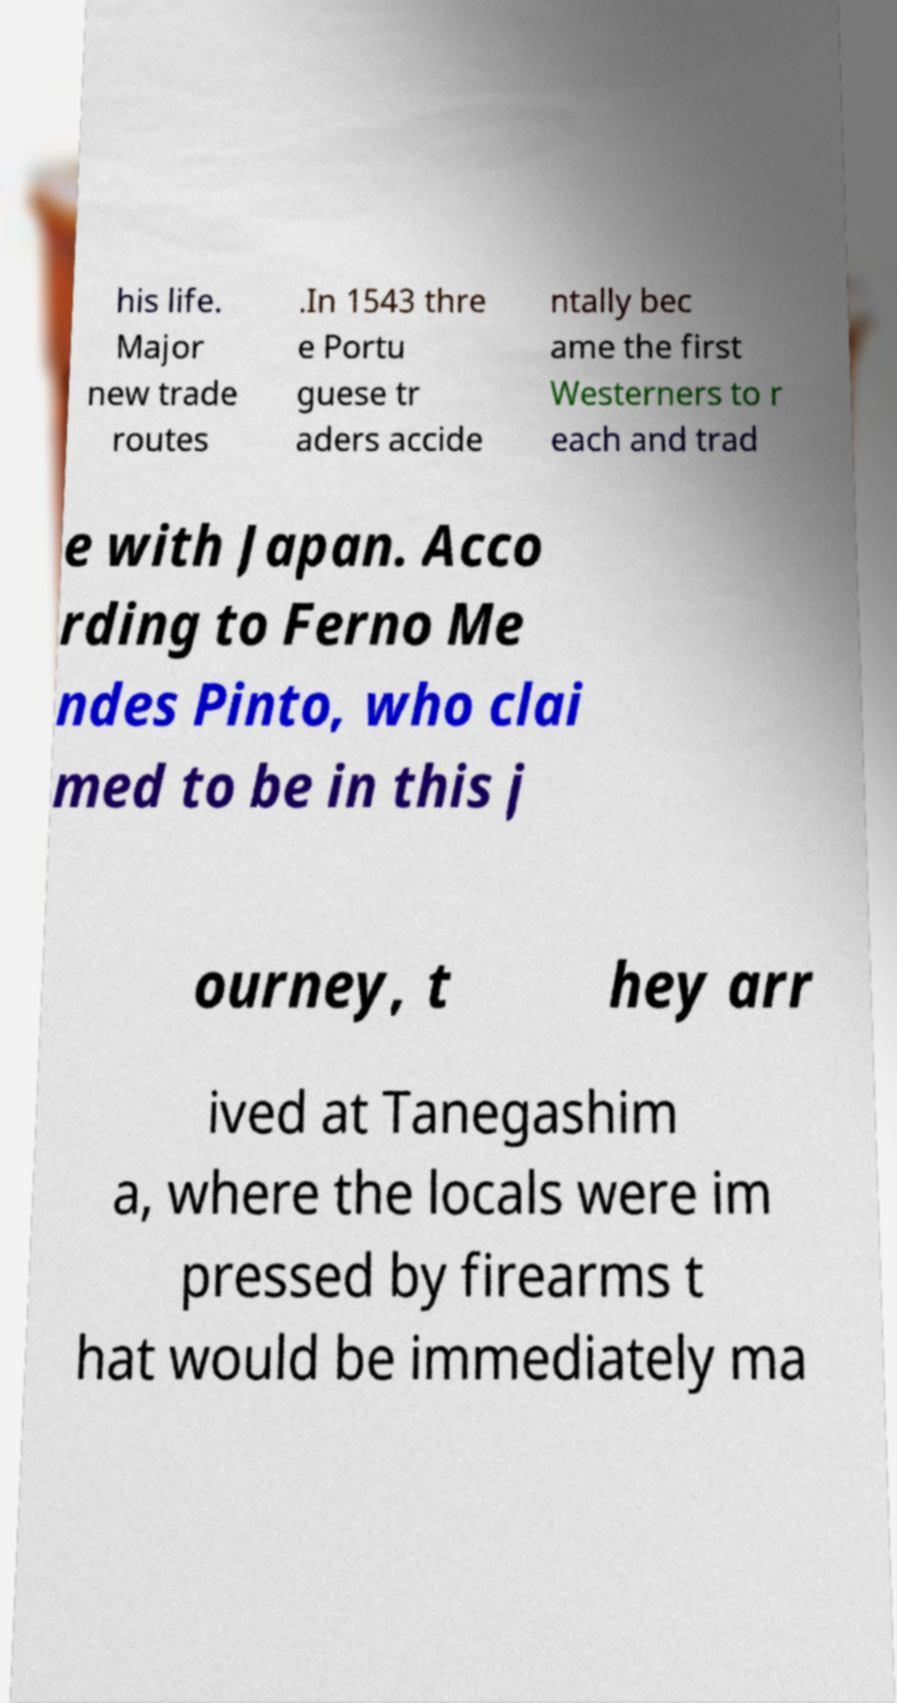Please read and relay the text visible in this image. What does it say? his life. Major new trade routes .In 1543 thre e Portu guese tr aders accide ntally bec ame the first Westerners to r each and trad e with Japan. Acco rding to Ferno Me ndes Pinto, who clai med to be in this j ourney, t hey arr ived at Tanegashim a, where the locals were im pressed by firearms t hat would be immediately ma 